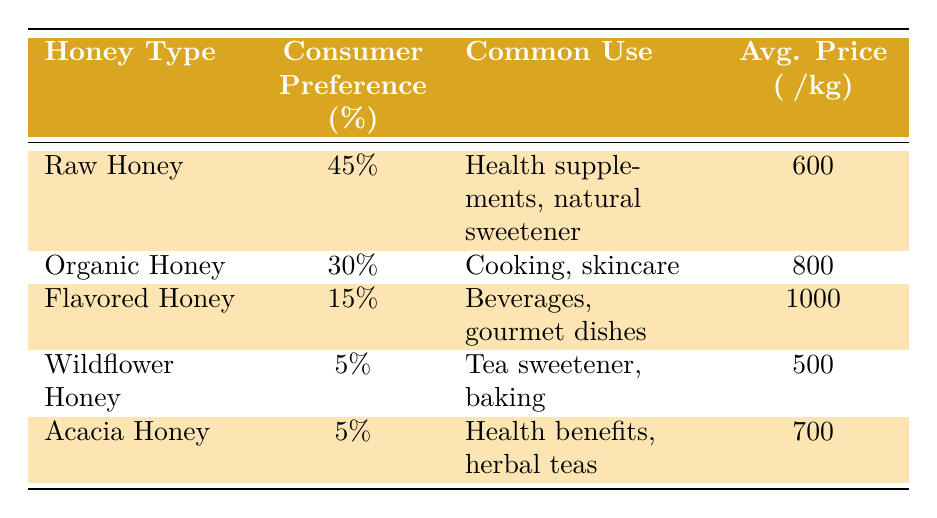What's the consumer preference percentage for Raw Honey? The table clearly states that the consumer preference percentage for Raw Honey is 45%.
Answer: 45% Which honey type has the highest average price per kg? By examining the average price per kg for each honey type, Flavored Honey has the highest price at ₹1000 per kg, while all others are lower.
Answer: Flavored Honey Is the consumer preference percentage for Organic Honey greater than that for Wildflower Honey? The consumer preference for Organic Honey is 30% and for Wildflower Honey it is 5%. Since 30% is greater than 5%, the statement is true.
Answer: Yes What is the combined consumer preference percentage for Raw and Organic Honey? The consumer preference for Raw Honey is 45% and for Organic Honey is 30%. By adding them together, 45% + 30% = 75%.
Answer: 75% Which honey types are primarily used for health benefits? According to the table, Raw Honey and Acacia Honey are mentioned for health benefits. Raw Honey is used in health supplements and Acacia Honey is used for health benefits in herbal teas.
Answer: Raw Honey and Acacia Honey What is the total average price per kg for all the honey types combined? The average prices are ₹600, ₹800, ₹1000, ₹500, and ₹700. Adding these gives a total of ₹600 + ₹800 + ₹1000 + ₹500 + ₹700 = ₹3600. To find the average, we divide by the number of honey types, which is 5: ₹3600 / 5 = ₹720.
Answer: ₹720 Which honey type has the lowest consumer preference percentage? Upon reviewing the table, both Wildflower Honey and Acacia Honey have the lowest consumer preference percentage, which is 5%.
Answer: Wildflower Honey and Acacia Honey Is it true that Flavored Honey is primarily used for health supplements? The table shows that Flavored Honey is primarily used in beverages and gourmet dishes, not health supplements. So the statement is false.
Answer: No 